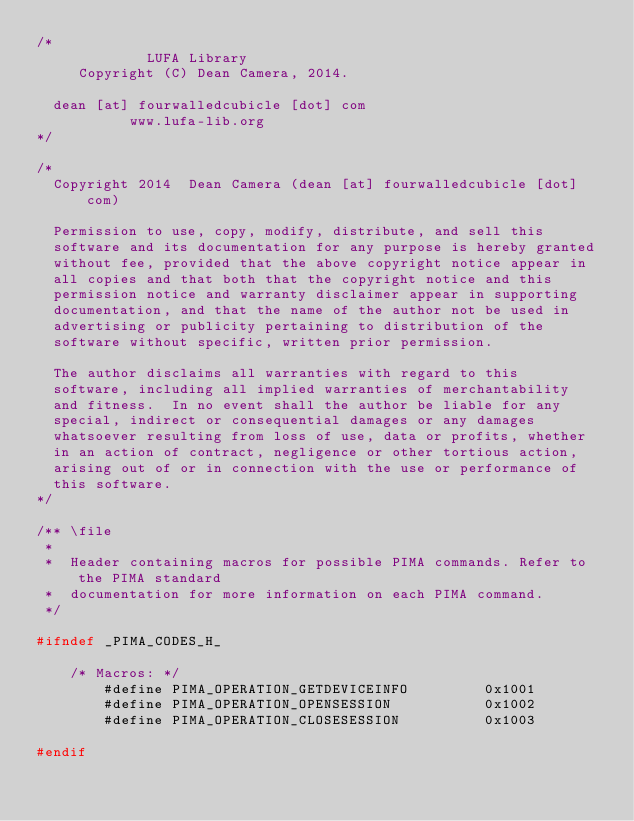<code> <loc_0><loc_0><loc_500><loc_500><_C_>/*
             LUFA Library
     Copyright (C) Dean Camera, 2014.

  dean [at] fourwalledcubicle [dot] com
           www.lufa-lib.org
*/

/*
  Copyright 2014  Dean Camera (dean [at] fourwalledcubicle [dot] com)

  Permission to use, copy, modify, distribute, and sell this
  software and its documentation for any purpose is hereby granted
  without fee, provided that the above copyright notice appear in
  all copies and that both that the copyright notice and this
  permission notice and warranty disclaimer appear in supporting
  documentation, and that the name of the author not be used in
  advertising or publicity pertaining to distribution of the
  software without specific, written prior permission.

  The author disclaims all warranties with regard to this
  software, including all implied warranties of merchantability
  and fitness.  In no event shall the author be liable for any
  special, indirect or consequential damages or any damages
  whatsoever resulting from loss of use, data or profits, whether
  in an action of contract, negligence or other tortious action,
  arising out of or in connection with the use or performance of
  this software.
*/

/** \file
 *
 *  Header containing macros for possible PIMA commands. Refer to the PIMA standard
 *  documentation for more information on each PIMA command.
 */

#ifndef _PIMA_CODES_H_

	/* Macros: */
		#define PIMA_OPERATION_GETDEVICEINFO         0x1001
		#define PIMA_OPERATION_OPENSESSION           0x1002
		#define PIMA_OPERATION_CLOSESESSION          0x1003

#endif

</code> 